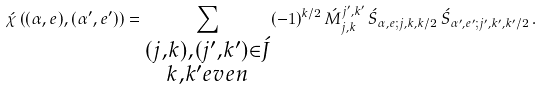Convert formula to latex. <formula><loc_0><loc_0><loc_500><loc_500>\acute { \chi } \left ( ( \alpha , e ) , ( \alpha ^ { \prime } , e ^ { \prime } ) \right ) = \sum _ { \substack { ( j , k ) , ( j ^ { \prime } , k ^ { \prime } ) \in \acute { J } \\ k , k ^ { \prime } e v e n } } ( - 1 ) ^ { k / 2 } \, \acute { M } _ { j , k } ^ { j ^ { \prime } , k ^ { \prime } } \, \acute { S } _ { \alpha , e ; j , k , k / 2 } \, \acute { S } _ { \alpha ^ { \prime } , e ^ { \prime } ; j ^ { \prime } , k ^ { \prime } , k ^ { \prime } / 2 } \, .</formula> 